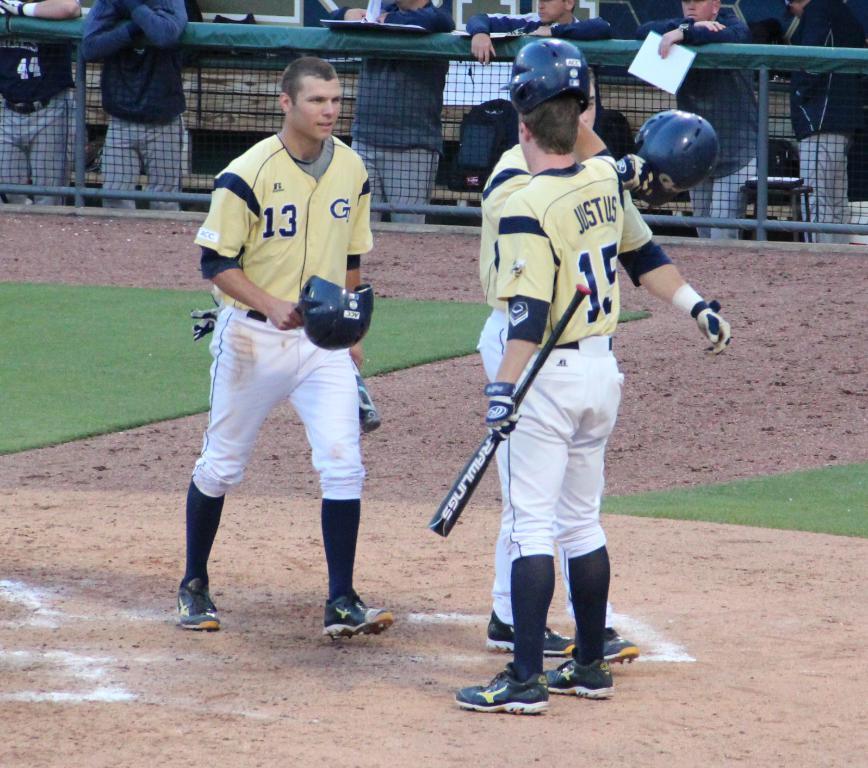What number jersey is that?
Offer a very short reply. 13. What is the players name?
Offer a terse response. Justus. 